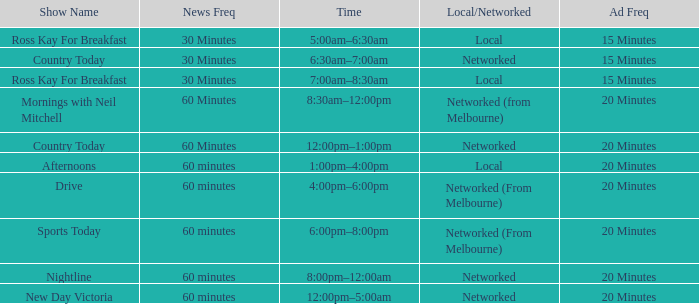What Local/Networked has a Show Name of nightline? Networked. 